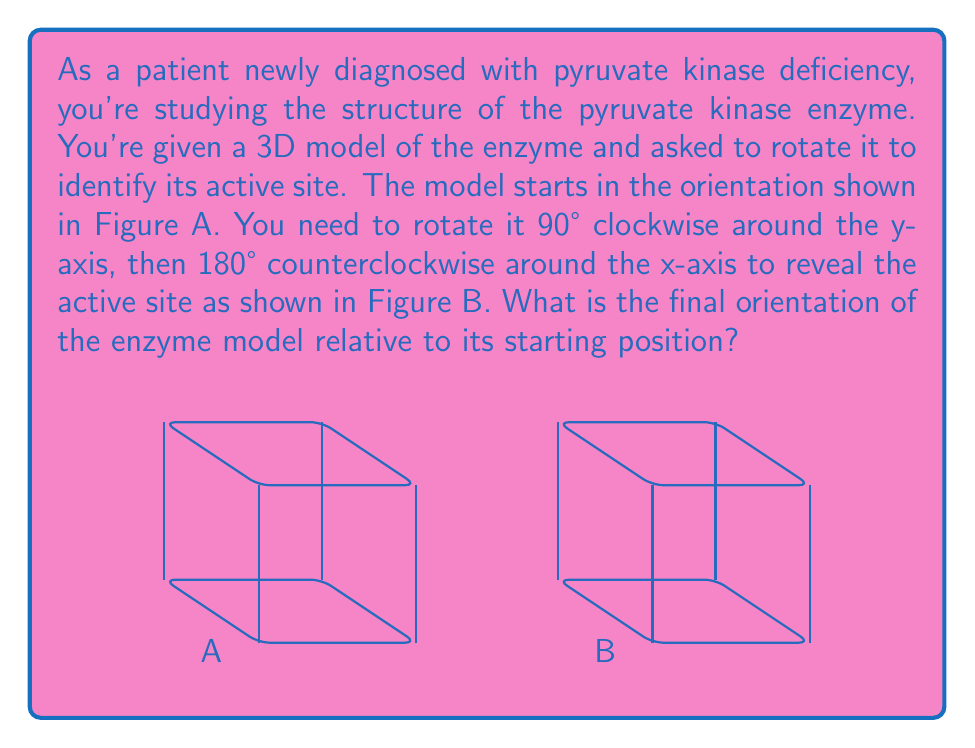Give your solution to this math problem. To solve this problem, we need to follow these steps:

1) First rotation: 90° clockwise around the y-axis
   This rotation can be represented by the matrix:
   $$R_y(90°) = \begin{pmatrix} 
   0 & 0 & 1 \\
   0 & 1 & 0 \\
   -1 & 0 & 0
   \end{pmatrix}$$

2) Second rotation: 180° counterclockwise around the x-axis
   This rotation can be represented by the matrix:
   $$R_x(180°) = \begin{pmatrix}
   1 & 0 & 0 \\
   0 & -1 & 0 \\
   0 & 0 & -1
   \end{pmatrix}$$

3) To get the final orientation, we multiply these matrices in the order of application:
   $$R_{final} = R_x(180°) \cdot R_y(90°) = \begin{pmatrix}
   1 & 0 & 0 \\
   0 & -1 & 0 \\
   0 & 0 & -1
   \end{pmatrix} \cdot \begin{pmatrix}
   0 & 0 & 1 \\
   0 & 1 & 0 \\
   -1 & 0 & 0
   \end{pmatrix} = \begin{pmatrix}
   0 & 0 & 1 \\
   0 & -1 & 0 \\
   1 & 0 & 0
   \end{pmatrix}$$

4) Interpreting this final rotation matrix:
   - The first column (0, 0, 1) indicates that the x-axis is now pointing in the positive z direction.
   - The second column (0, -1, 0) indicates that the y-axis is now pointing in the negative y direction.
   - The third column (1, 0, 0) indicates that the z-axis is now pointing in the positive x direction.

5) In terms of axis transformations:
   - x → z
   - y → -y
   - z → x

This means the enzyme model has been rotated so that its original x-axis now points along the positive z-axis, its y-axis points along the negative y-axis, and its z-axis points along the positive x-axis.
Answer: x → z, y → -y, z → x 